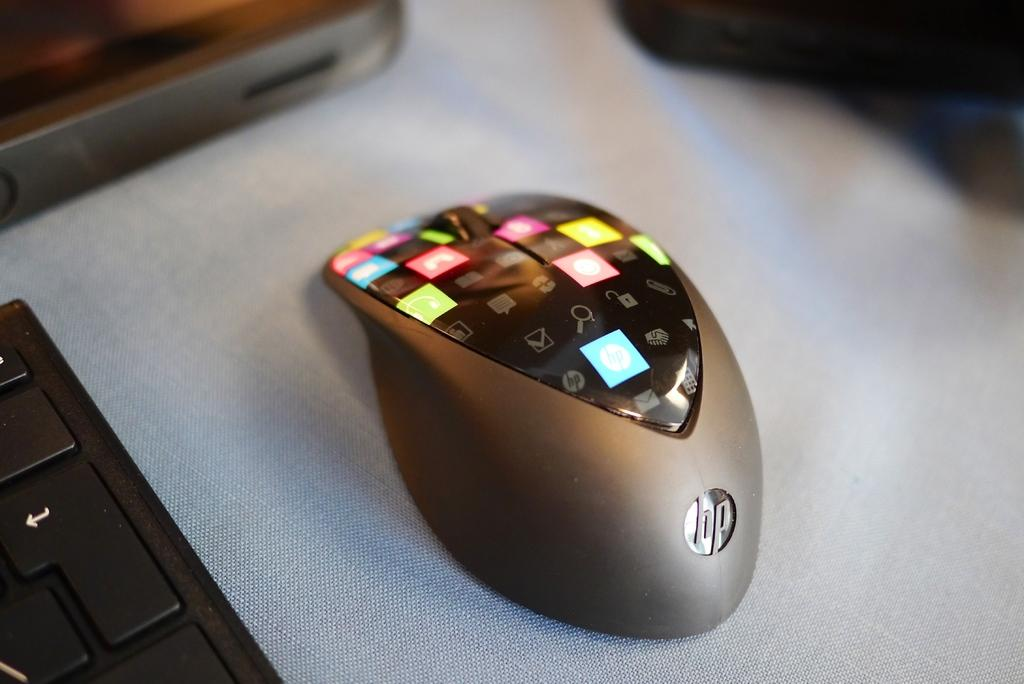<image>
Write a terse but informative summary of the picture. An HP mouse with lit up icons on the top sits next to a black keyboard. 